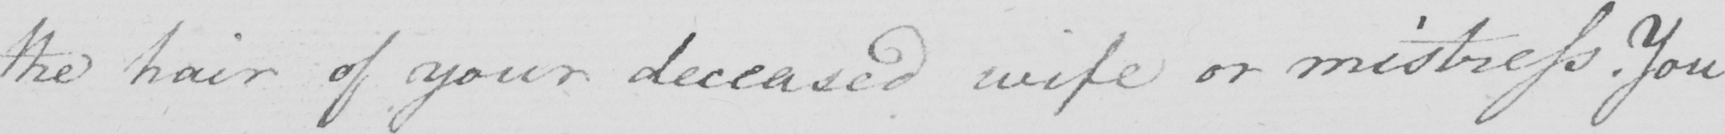What does this handwritten line say? the hair of your deceased wife or mistress . You 